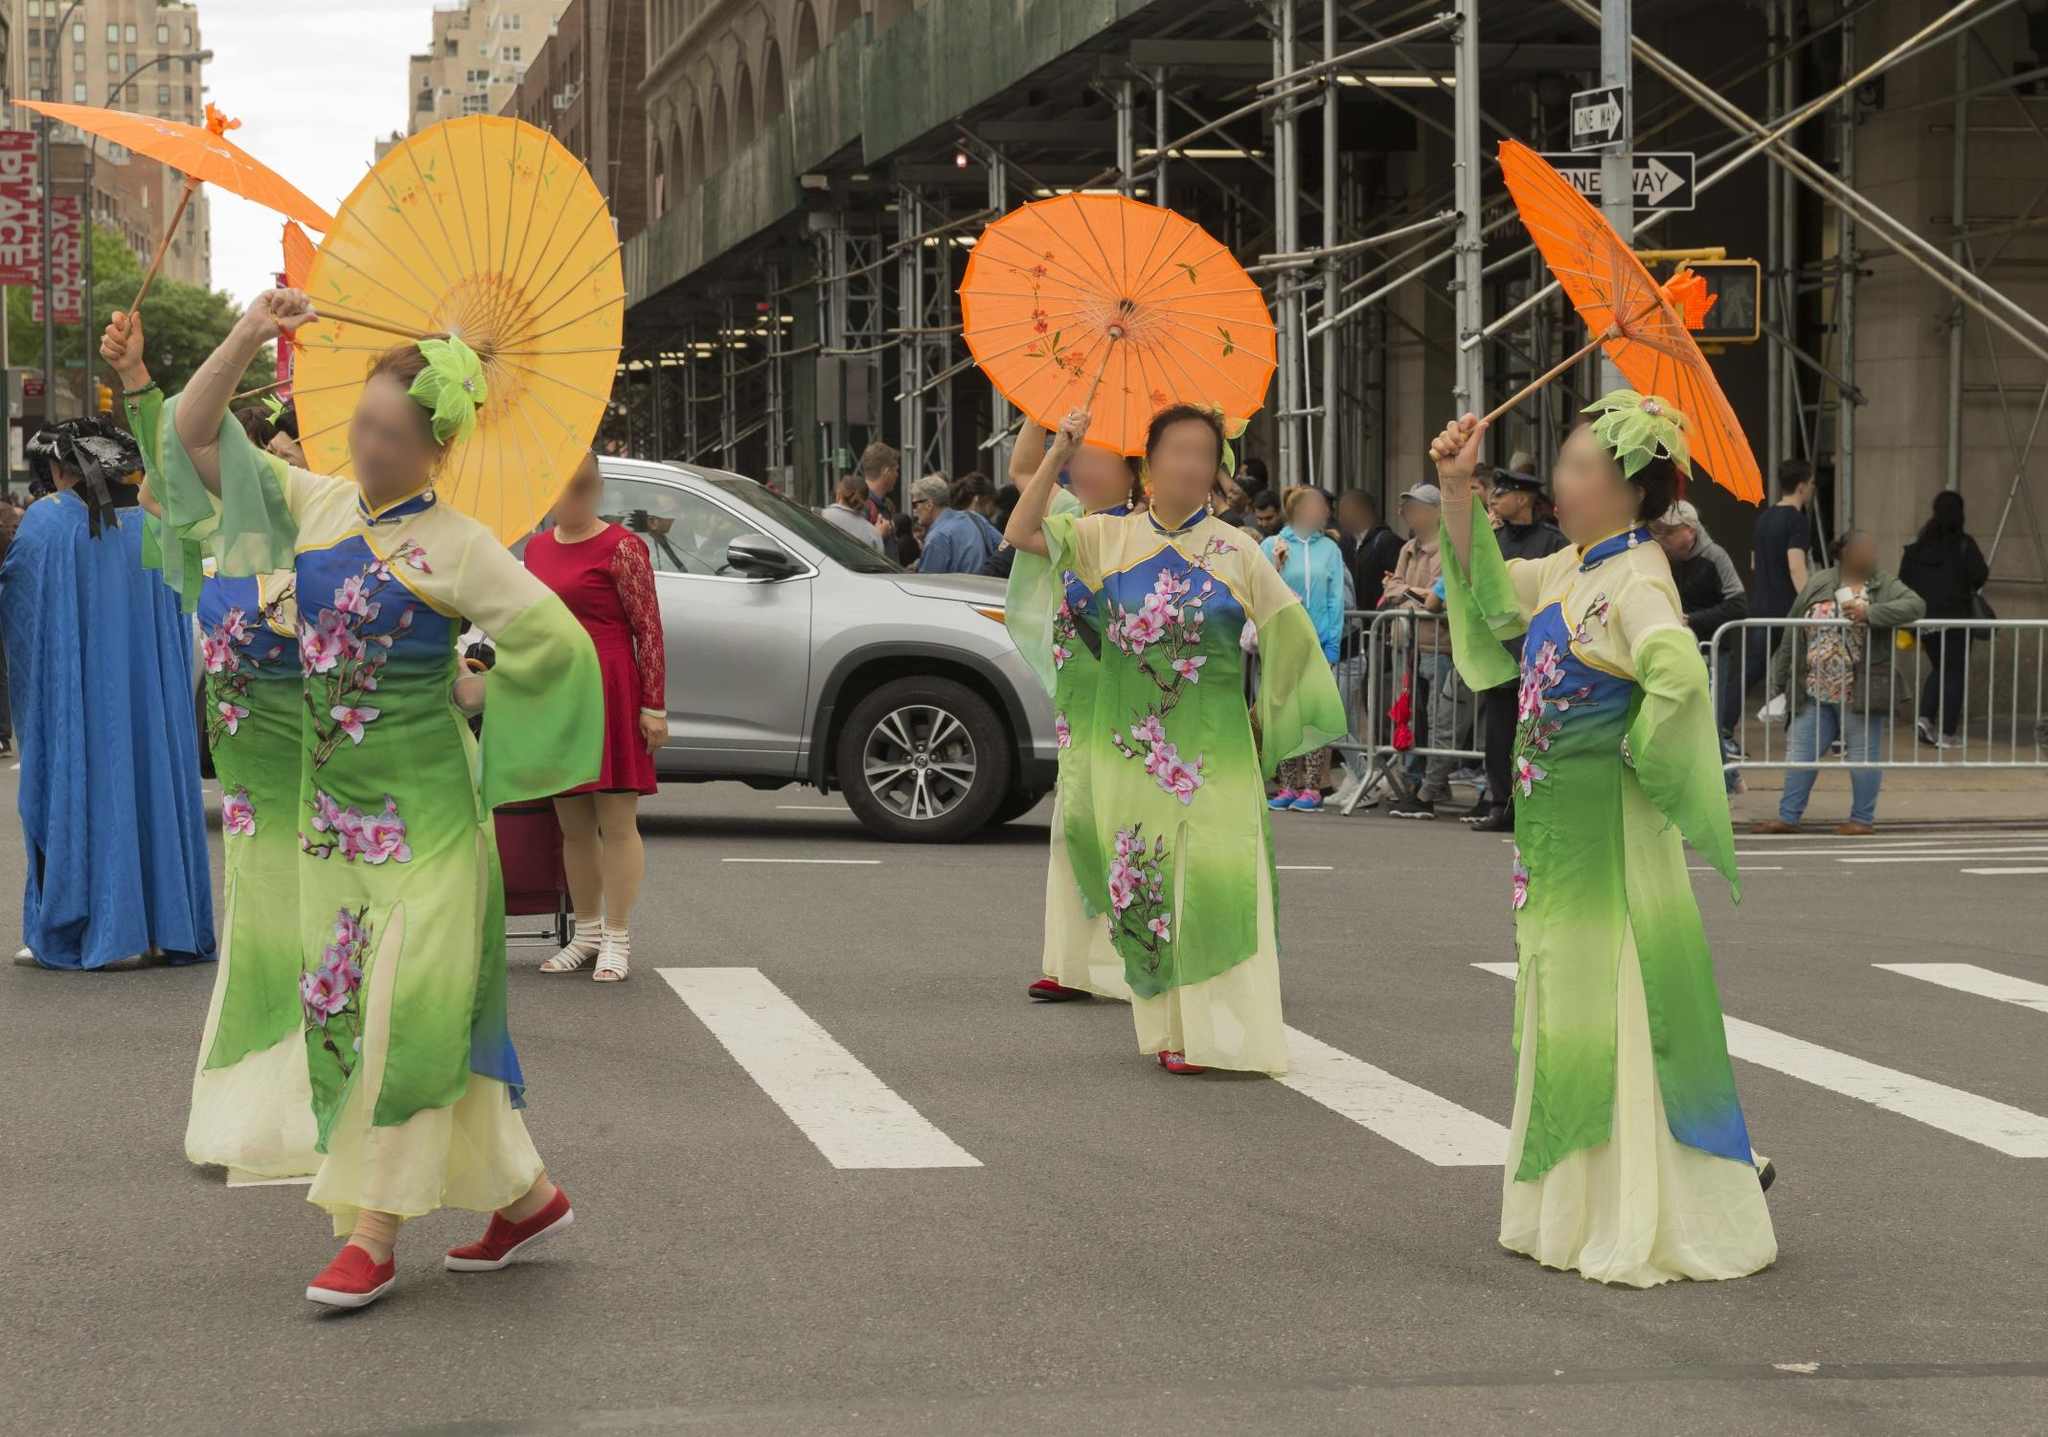Imagine the emotions and thoughts of the women participating in the parade. As the women gracefully walk down the street, they likely feel a mix of pride, joy, and a sense of belonging. Wearing their traditional attire and holding parasols, they may be reflecting on their cultural heritage and the importance of preserving these traditions. The vibrancy of the parade and the attention of the crowd might instill a sense of excitement and honor in representing their culture to the world. 